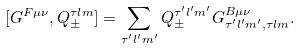<formula> <loc_0><loc_0><loc_500><loc_500>[ G ^ { F \mu \nu } , Q ^ { \tau l m } _ { \pm } ] = \sum _ { \tau ^ { \prime } l ^ { \prime } m ^ { \prime } } Q ^ { \tau ^ { \prime } l ^ { \prime } m ^ { \prime } } _ { \pm } G ^ { B \mu \nu } _ { \tau ^ { \prime } l ^ { \prime } m ^ { \prime } , \tau l m } .</formula> 